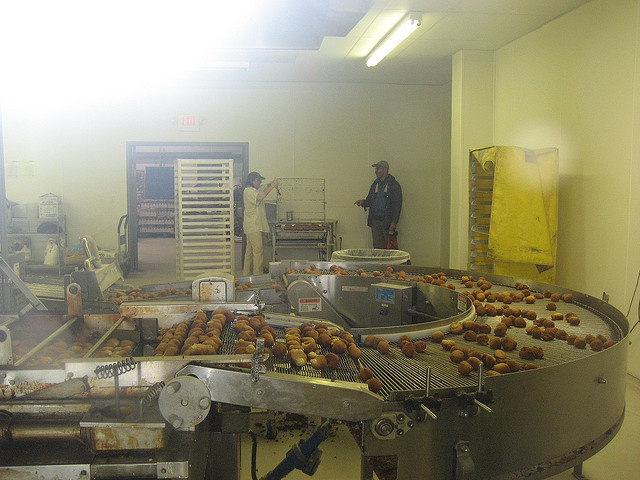Describe the objects in this image and their specific colors. I can see people in white, black, gray, and purple tones, people in white, gray, and tan tones, donut in white, maroon, olive, and black tones, donut in white, maroon, black, and olive tones, and donut in white, black, maroon, and olive tones in this image. 